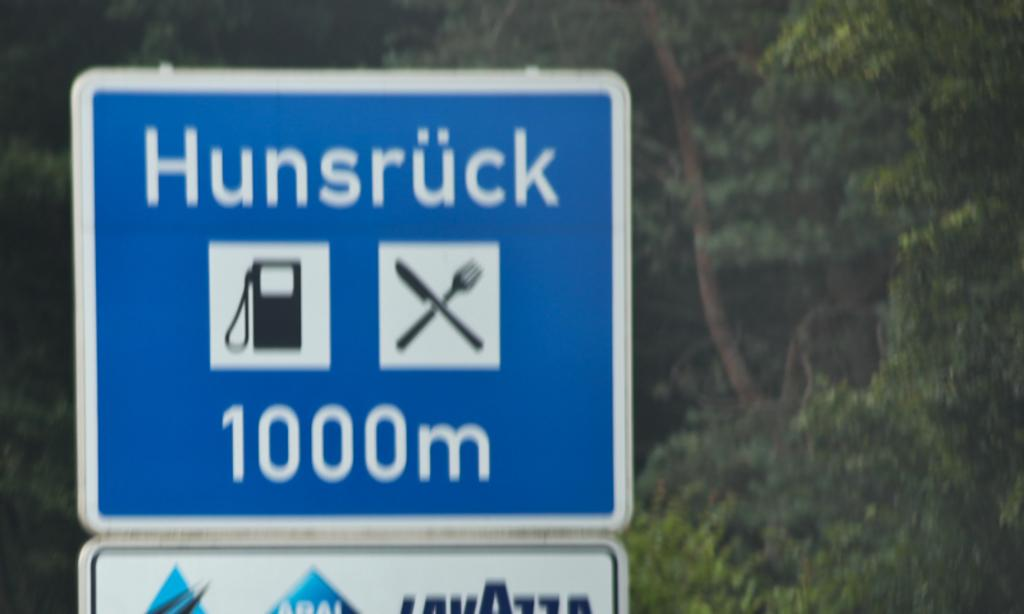<image>
Summarize the visual content of the image. roadsign that show Hunsruck is in 1000m and has food and gas places 